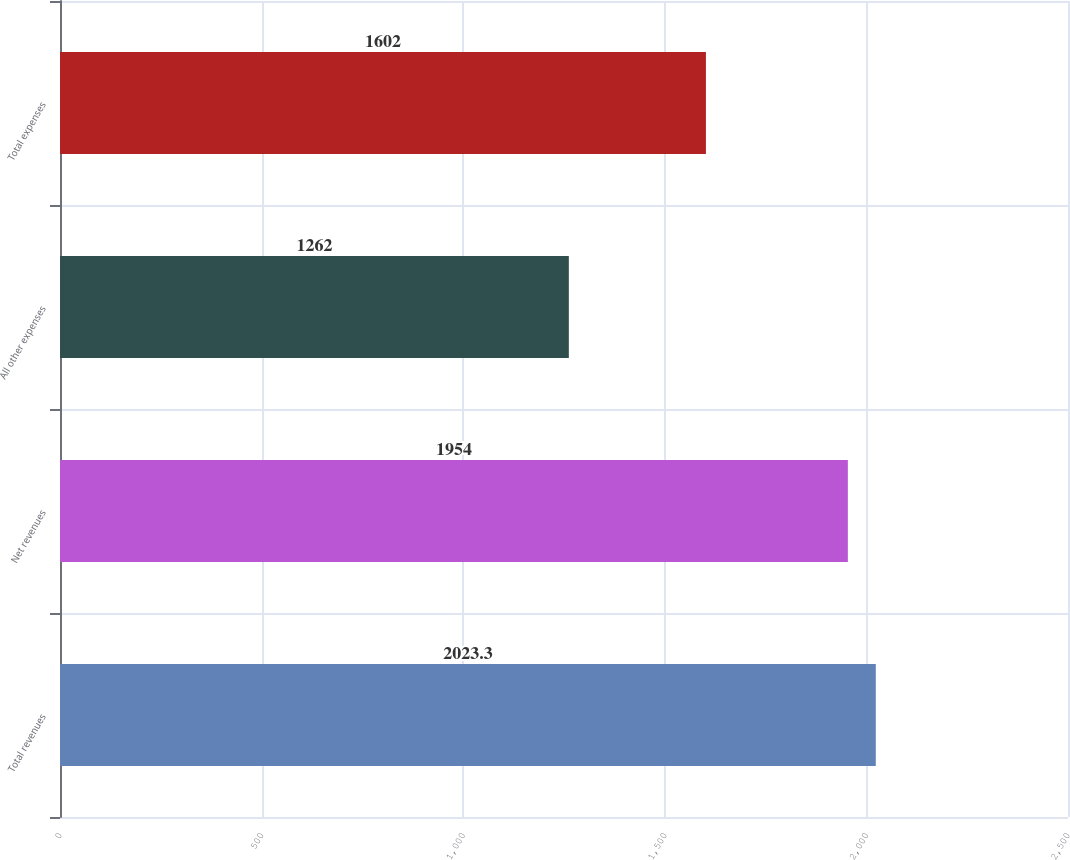<chart> <loc_0><loc_0><loc_500><loc_500><bar_chart><fcel>Total revenues<fcel>Net revenues<fcel>All other expenses<fcel>Total expenses<nl><fcel>2023.3<fcel>1954<fcel>1262<fcel>1602<nl></chart> 